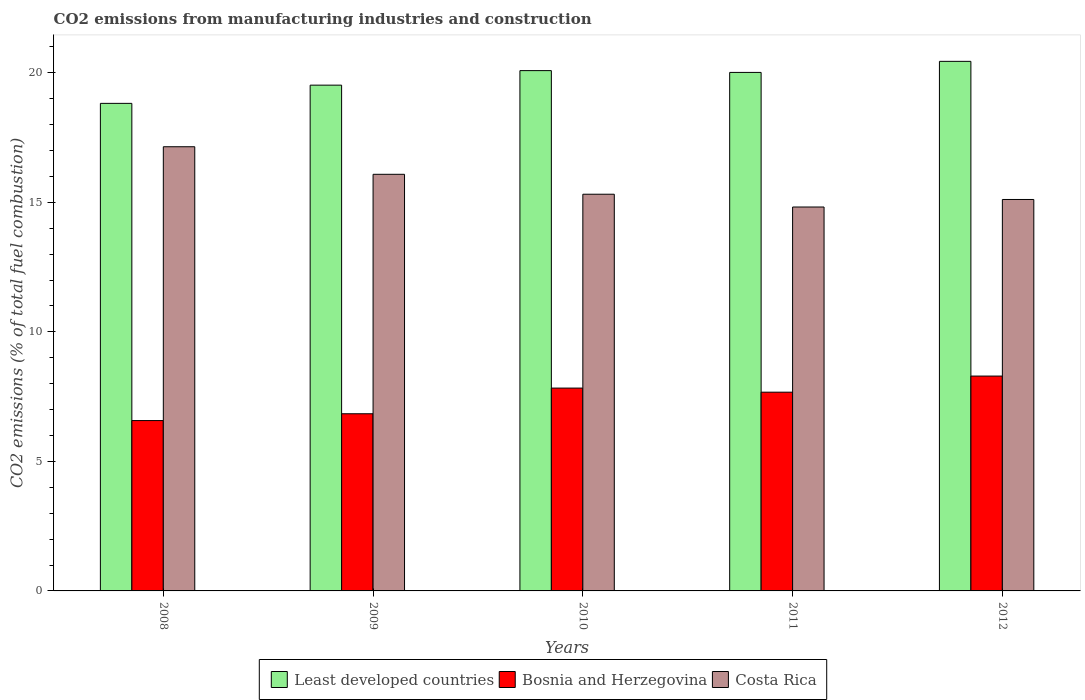How many groups of bars are there?
Your answer should be very brief. 5. Are the number of bars per tick equal to the number of legend labels?
Make the answer very short. Yes. What is the amount of CO2 emitted in Bosnia and Herzegovina in 2010?
Ensure brevity in your answer.  7.83. Across all years, what is the maximum amount of CO2 emitted in Costa Rica?
Provide a short and direct response. 17.15. Across all years, what is the minimum amount of CO2 emitted in Least developed countries?
Provide a short and direct response. 18.82. In which year was the amount of CO2 emitted in Bosnia and Herzegovina maximum?
Your answer should be compact. 2012. What is the total amount of CO2 emitted in Least developed countries in the graph?
Keep it short and to the point. 98.89. What is the difference between the amount of CO2 emitted in Bosnia and Herzegovina in 2008 and that in 2011?
Your answer should be compact. -1.1. What is the difference between the amount of CO2 emitted in Bosnia and Herzegovina in 2008 and the amount of CO2 emitted in Costa Rica in 2011?
Your answer should be compact. -8.24. What is the average amount of CO2 emitted in Costa Rica per year?
Offer a terse response. 15.7. In the year 2012, what is the difference between the amount of CO2 emitted in Least developed countries and amount of CO2 emitted in Bosnia and Herzegovina?
Your response must be concise. 12.15. In how many years, is the amount of CO2 emitted in Costa Rica greater than 11 %?
Your response must be concise. 5. What is the ratio of the amount of CO2 emitted in Costa Rica in 2009 to that in 2012?
Your answer should be compact. 1.06. What is the difference between the highest and the second highest amount of CO2 emitted in Least developed countries?
Make the answer very short. 0.36. What is the difference between the highest and the lowest amount of CO2 emitted in Bosnia and Herzegovina?
Your answer should be compact. 1.72. What does the 3rd bar from the left in 2009 represents?
Make the answer very short. Costa Rica. What does the 3rd bar from the right in 2008 represents?
Provide a succinct answer. Least developed countries. How many bars are there?
Offer a terse response. 15. How many years are there in the graph?
Provide a succinct answer. 5. What is the difference between two consecutive major ticks on the Y-axis?
Your answer should be compact. 5. Are the values on the major ticks of Y-axis written in scientific E-notation?
Provide a succinct answer. No. Does the graph contain any zero values?
Make the answer very short. No. Does the graph contain grids?
Ensure brevity in your answer.  No. Where does the legend appear in the graph?
Give a very brief answer. Bottom center. How many legend labels are there?
Give a very brief answer. 3. What is the title of the graph?
Offer a terse response. CO2 emissions from manufacturing industries and construction. What is the label or title of the Y-axis?
Keep it short and to the point. CO2 emissions (% of total fuel combustion). What is the CO2 emissions (% of total fuel combustion) in Least developed countries in 2008?
Your answer should be very brief. 18.82. What is the CO2 emissions (% of total fuel combustion) in Bosnia and Herzegovina in 2008?
Give a very brief answer. 6.58. What is the CO2 emissions (% of total fuel combustion) in Costa Rica in 2008?
Your answer should be compact. 17.15. What is the CO2 emissions (% of total fuel combustion) in Least developed countries in 2009?
Your answer should be compact. 19.52. What is the CO2 emissions (% of total fuel combustion) in Bosnia and Herzegovina in 2009?
Offer a very short reply. 6.84. What is the CO2 emissions (% of total fuel combustion) in Costa Rica in 2009?
Provide a succinct answer. 16.08. What is the CO2 emissions (% of total fuel combustion) of Least developed countries in 2010?
Make the answer very short. 20.09. What is the CO2 emissions (% of total fuel combustion) of Bosnia and Herzegovina in 2010?
Make the answer very short. 7.83. What is the CO2 emissions (% of total fuel combustion) of Costa Rica in 2010?
Give a very brief answer. 15.31. What is the CO2 emissions (% of total fuel combustion) in Least developed countries in 2011?
Give a very brief answer. 20.02. What is the CO2 emissions (% of total fuel combustion) in Bosnia and Herzegovina in 2011?
Make the answer very short. 7.67. What is the CO2 emissions (% of total fuel combustion) of Costa Rica in 2011?
Keep it short and to the point. 14.82. What is the CO2 emissions (% of total fuel combustion) in Least developed countries in 2012?
Your answer should be very brief. 20.44. What is the CO2 emissions (% of total fuel combustion) in Bosnia and Herzegovina in 2012?
Keep it short and to the point. 8.29. What is the CO2 emissions (% of total fuel combustion) in Costa Rica in 2012?
Give a very brief answer. 15.11. Across all years, what is the maximum CO2 emissions (% of total fuel combustion) of Least developed countries?
Make the answer very short. 20.44. Across all years, what is the maximum CO2 emissions (% of total fuel combustion) of Bosnia and Herzegovina?
Make the answer very short. 8.29. Across all years, what is the maximum CO2 emissions (% of total fuel combustion) in Costa Rica?
Provide a succinct answer. 17.15. Across all years, what is the minimum CO2 emissions (% of total fuel combustion) in Least developed countries?
Provide a short and direct response. 18.82. Across all years, what is the minimum CO2 emissions (% of total fuel combustion) in Bosnia and Herzegovina?
Your answer should be compact. 6.58. Across all years, what is the minimum CO2 emissions (% of total fuel combustion) of Costa Rica?
Your answer should be very brief. 14.82. What is the total CO2 emissions (% of total fuel combustion) in Least developed countries in the graph?
Offer a terse response. 98.89. What is the total CO2 emissions (% of total fuel combustion) of Bosnia and Herzegovina in the graph?
Offer a very short reply. 37.21. What is the total CO2 emissions (% of total fuel combustion) of Costa Rica in the graph?
Offer a terse response. 78.48. What is the difference between the CO2 emissions (% of total fuel combustion) in Least developed countries in 2008 and that in 2009?
Ensure brevity in your answer.  -0.7. What is the difference between the CO2 emissions (% of total fuel combustion) of Bosnia and Herzegovina in 2008 and that in 2009?
Give a very brief answer. -0.26. What is the difference between the CO2 emissions (% of total fuel combustion) in Costa Rica in 2008 and that in 2009?
Your response must be concise. 1.06. What is the difference between the CO2 emissions (% of total fuel combustion) in Least developed countries in 2008 and that in 2010?
Your response must be concise. -1.26. What is the difference between the CO2 emissions (% of total fuel combustion) in Bosnia and Herzegovina in 2008 and that in 2010?
Give a very brief answer. -1.25. What is the difference between the CO2 emissions (% of total fuel combustion) in Costa Rica in 2008 and that in 2010?
Offer a very short reply. 1.83. What is the difference between the CO2 emissions (% of total fuel combustion) in Least developed countries in 2008 and that in 2011?
Make the answer very short. -1.2. What is the difference between the CO2 emissions (% of total fuel combustion) of Bosnia and Herzegovina in 2008 and that in 2011?
Ensure brevity in your answer.  -1.1. What is the difference between the CO2 emissions (% of total fuel combustion) in Costa Rica in 2008 and that in 2011?
Offer a very short reply. 2.33. What is the difference between the CO2 emissions (% of total fuel combustion) in Least developed countries in 2008 and that in 2012?
Offer a very short reply. -1.62. What is the difference between the CO2 emissions (% of total fuel combustion) of Bosnia and Herzegovina in 2008 and that in 2012?
Keep it short and to the point. -1.72. What is the difference between the CO2 emissions (% of total fuel combustion) of Costa Rica in 2008 and that in 2012?
Provide a succinct answer. 2.04. What is the difference between the CO2 emissions (% of total fuel combustion) of Least developed countries in 2009 and that in 2010?
Your answer should be very brief. -0.56. What is the difference between the CO2 emissions (% of total fuel combustion) of Bosnia and Herzegovina in 2009 and that in 2010?
Ensure brevity in your answer.  -0.99. What is the difference between the CO2 emissions (% of total fuel combustion) in Costa Rica in 2009 and that in 2010?
Your response must be concise. 0.77. What is the difference between the CO2 emissions (% of total fuel combustion) in Least developed countries in 2009 and that in 2011?
Offer a terse response. -0.49. What is the difference between the CO2 emissions (% of total fuel combustion) of Bosnia and Herzegovina in 2009 and that in 2011?
Keep it short and to the point. -0.83. What is the difference between the CO2 emissions (% of total fuel combustion) in Costa Rica in 2009 and that in 2011?
Your answer should be very brief. 1.26. What is the difference between the CO2 emissions (% of total fuel combustion) in Least developed countries in 2009 and that in 2012?
Your answer should be compact. -0.92. What is the difference between the CO2 emissions (% of total fuel combustion) in Bosnia and Herzegovina in 2009 and that in 2012?
Your response must be concise. -1.46. What is the difference between the CO2 emissions (% of total fuel combustion) of Costa Rica in 2009 and that in 2012?
Keep it short and to the point. 0.97. What is the difference between the CO2 emissions (% of total fuel combustion) of Least developed countries in 2010 and that in 2011?
Provide a short and direct response. 0.07. What is the difference between the CO2 emissions (% of total fuel combustion) in Bosnia and Herzegovina in 2010 and that in 2011?
Make the answer very short. 0.16. What is the difference between the CO2 emissions (% of total fuel combustion) of Costa Rica in 2010 and that in 2011?
Provide a short and direct response. 0.49. What is the difference between the CO2 emissions (% of total fuel combustion) in Least developed countries in 2010 and that in 2012?
Keep it short and to the point. -0.36. What is the difference between the CO2 emissions (% of total fuel combustion) of Bosnia and Herzegovina in 2010 and that in 2012?
Provide a short and direct response. -0.46. What is the difference between the CO2 emissions (% of total fuel combustion) of Costa Rica in 2010 and that in 2012?
Your answer should be very brief. 0.2. What is the difference between the CO2 emissions (% of total fuel combustion) of Least developed countries in 2011 and that in 2012?
Your response must be concise. -0.43. What is the difference between the CO2 emissions (% of total fuel combustion) in Bosnia and Herzegovina in 2011 and that in 2012?
Your response must be concise. -0.62. What is the difference between the CO2 emissions (% of total fuel combustion) of Costa Rica in 2011 and that in 2012?
Offer a very short reply. -0.29. What is the difference between the CO2 emissions (% of total fuel combustion) of Least developed countries in 2008 and the CO2 emissions (% of total fuel combustion) of Bosnia and Herzegovina in 2009?
Give a very brief answer. 11.98. What is the difference between the CO2 emissions (% of total fuel combustion) of Least developed countries in 2008 and the CO2 emissions (% of total fuel combustion) of Costa Rica in 2009?
Your response must be concise. 2.74. What is the difference between the CO2 emissions (% of total fuel combustion) in Bosnia and Herzegovina in 2008 and the CO2 emissions (% of total fuel combustion) in Costa Rica in 2009?
Offer a terse response. -9.51. What is the difference between the CO2 emissions (% of total fuel combustion) in Least developed countries in 2008 and the CO2 emissions (% of total fuel combustion) in Bosnia and Herzegovina in 2010?
Make the answer very short. 10.99. What is the difference between the CO2 emissions (% of total fuel combustion) of Least developed countries in 2008 and the CO2 emissions (% of total fuel combustion) of Costa Rica in 2010?
Ensure brevity in your answer.  3.51. What is the difference between the CO2 emissions (% of total fuel combustion) in Bosnia and Herzegovina in 2008 and the CO2 emissions (% of total fuel combustion) in Costa Rica in 2010?
Ensure brevity in your answer.  -8.74. What is the difference between the CO2 emissions (% of total fuel combustion) of Least developed countries in 2008 and the CO2 emissions (% of total fuel combustion) of Bosnia and Herzegovina in 2011?
Your response must be concise. 11.15. What is the difference between the CO2 emissions (% of total fuel combustion) of Least developed countries in 2008 and the CO2 emissions (% of total fuel combustion) of Costa Rica in 2011?
Your answer should be very brief. 4. What is the difference between the CO2 emissions (% of total fuel combustion) of Bosnia and Herzegovina in 2008 and the CO2 emissions (% of total fuel combustion) of Costa Rica in 2011?
Provide a succinct answer. -8.24. What is the difference between the CO2 emissions (% of total fuel combustion) of Least developed countries in 2008 and the CO2 emissions (% of total fuel combustion) of Bosnia and Herzegovina in 2012?
Keep it short and to the point. 10.53. What is the difference between the CO2 emissions (% of total fuel combustion) in Least developed countries in 2008 and the CO2 emissions (% of total fuel combustion) in Costa Rica in 2012?
Your answer should be compact. 3.71. What is the difference between the CO2 emissions (% of total fuel combustion) of Bosnia and Herzegovina in 2008 and the CO2 emissions (% of total fuel combustion) of Costa Rica in 2012?
Offer a very short reply. -8.53. What is the difference between the CO2 emissions (% of total fuel combustion) in Least developed countries in 2009 and the CO2 emissions (% of total fuel combustion) in Bosnia and Herzegovina in 2010?
Offer a terse response. 11.69. What is the difference between the CO2 emissions (% of total fuel combustion) of Least developed countries in 2009 and the CO2 emissions (% of total fuel combustion) of Costa Rica in 2010?
Offer a very short reply. 4.21. What is the difference between the CO2 emissions (% of total fuel combustion) in Bosnia and Herzegovina in 2009 and the CO2 emissions (% of total fuel combustion) in Costa Rica in 2010?
Provide a short and direct response. -8.47. What is the difference between the CO2 emissions (% of total fuel combustion) in Least developed countries in 2009 and the CO2 emissions (% of total fuel combustion) in Bosnia and Herzegovina in 2011?
Offer a very short reply. 11.85. What is the difference between the CO2 emissions (% of total fuel combustion) of Least developed countries in 2009 and the CO2 emissions (% of total fuel combustion) of Costa Rica in 2011?
Your answer should be very brief. 4.7. What is the difference between the CO2 emissions (% of total fuel combustion) of Bosnia and Herzegovina in 2009 and the CO2 emissions (% of total fuel combustion) of Costa Rica in 2011?
Your answer should be compact. -7.98. What is the difference between the CO2 emissions (% of total fuel combustion) of Least developed countries in 2009 and the CO2 emissions (% of total fuel combustion) of Bosnia and Herzegovina in 2012?
Your answer should be very brief. 11.23. What is the difference between the CO2 emissions (% of total fuel combustion) in Least developed countries in 2009 and the CO2 emissions (% of total fuel combustion) in Costa Rica in 2012?
Your response must be concise. 4.41. What is the difference between the CO2 emissions (% of total fuel combustion) of Bosnia and Herzegovina in 2009 and the CO2 emissions (% of total fuel combustion) of Costa Rica in 2012?
Give a very brief answer. -8.27. What is the difference between the CO2 emissions (% of total fuel combustion) of Least developed countries in 2010 and the CO2 emissions (% of total fuel combustion) of Bosnia and Herzegovina in 2011?
Your answer should be compact. 12.41. What is the difference between the CO2 emissions (% of total fuel combustion) of Least developed countries in 2010 and the CO2 emissions (% of total fuel combustion) of Costa Rica in 2011?
Your answer should be very brief. 5.27. What is the difference between the CO2 emissions (% of total fuel combustion) of Bosnia and Herzegovina in 2010 and the CO2 emissions (% of total fuel combustion) of Costa Rica in 2011?
Ensure brevity in your answer.  -6.99. What is the difference between the CO2 emissions (% of total fuel combustion) in Least developed countries in 2010 and the CO2 emissions (% of total fuel combustion) in Bosnia and Herzegovina in 2012?
Your answer should be compact. 11.79. What is the difference between the CO2 emissions (% of total fuel combustion) of Least developed countries in 2010 and the CO2 emissions (% of total fuel combustion) of Costa Rica in 2012?
Make the answer very short. 4.97. What is the difference between the CO2 emissions (% of total fuel combustion) in Bosnia and Herzegovina in 2010 and the CO2 emissions (% of total fuel combustion) in Costa Rica in 2012?
Make the answer very short. -7.28. What is the difference between the CO2 emissions (% of total fuel combustion) of Least developed countries in 2011 and the CO2 emissions (% of total fuel combustion) of Bosnia and Herzegovina in 2012?
Your answer should be very brief. 11.72. What is the difference between the CO2 emissions (% of total fuel combustion) of Least developed countries in 2011 and the CO2 emissions (% of total fuel combustion) of Costa Rica in 2012?
Give a very brief answer. 4.91. What is the difference between the CO2 emissions (% of total fuel combustion) of Bosnia and Herzegovina in 2011 and the CO2 emissions (% of total fuel combustion) of Costa Rica in 2012?
Offer a very short reply. -7.44. What is the average CO2 emissions (% of total fuel combustion) in Least developed countries per year?
Keep it short and to the point. 19.78. What is the average CO2 emissions (% of total fuel combustion) in Bosnia and Herzegovina per year?
Ensure brevity in your answer.  7.44. What is the average CO2 emissions (% of total fuel combustion) in Costa Rica per year?
Your response must be concise. 15.7. In the year 2008, what is the difference between the CO2 emissions (% of total fuel combustion) of Least developed countries and CO2 emissions (% of total fuel combustion) of Bosnia and Herzegovina?
Offer a terse response. 12.24. In the year 2008, what is the difference between the CO2 emissions (% of total fuel combustion) of Least developed countries and CO2 emissions (% of total fuel combustion) of Costa Rica?
Provide a short and direct response. 1.67. In the year 2008, what is the difference between the CO2 emissions (% of total fuel combustion) of Bosnia and Herzegovina and CO2 emissions (% of total fuel combustion) of Costa Rica?
Keep it short and to the point. -10.57. In the year 2009, what is the difference between the CO2 emissions (% of total fuel combustion) in Least developed countries and CO2 emissions (% of total fuel combustion) in Bosnia and Herzegovina?
Keep it short and to the point. 12.69. In the year 2009, what is the difference between the CO2 emissions (% of total fuel combustion) of Least developed countries and CO2 emissions (% of total fuel combustion) of Costa Rica?
Offer a terse response. 3.44. In the year 2009, what is the difference between the CO2 emissions (% of total fuel combustion) in Bosnia and Herzegovina and CO2 emissions (% of total fuel combustion) in Costa Rica?
Ensure brevity in your answer.  -9.24. In the year 2010, what is the difference between the CO2 emissions (% of total fuel combustion) of Least developed countries and CO2 emissions (% of total fuel combustion) of Bosnia and Herzegovina?
Offer a terse response. 12.26. In the year 2010, what is the difference between the CO2 emissions (% of total fuel combustion) of Least developed countries and CO2 emissions (% of total fuel combustion) of Costa Rica?
Offer a very short reply. 4.77. In the year 2010, what is the difference between the CO2 emissions (% of total fuel combustion) of Bosnia and Herzegovina and CO2 emissions (% of total fuel combustion) of Costa Rica?
Your answer should be very brief. -7.48. In the year 2011, what is the difference between the CO2 emissions (% of total fuel combustion) of Least developed countries and CO2 emissions (% of total fuel combustion) of Bosnia and Herzegovina?
Offer a very short reply. 12.34. In the year 2011, what is the difference between the CO2 emissions (% of total fuel combustion) of Least developed countries and CO2 emissions (% of total fuel combustion) of Costa Rica?
Offer a terse response. 5.2. In the year 2011, what is the difference between the CO2 emissions (% of total fuel combustion) of Bosnia and Herzegovina and CO2 emissions (% of total fuel combustion) of Costa Rica?
Offer a very short reply. -7.15. In the year 2012, what is the difference between the CO2 emissions (% of total fuel combustion) in Least developed countries and CO2 emissions (% of total fuel combustion) in Bosnia and Herzegovina?
Offer a terse response. 12.15. In the year 2012, what is the difference between the CO2 emissions (% of total fuel combustion) of Least developed countries and CO2 emissions (% of total fuel combustion) of Costa Rica?
Your response must be concise. 5.33. In the year 2012, what is the difference between the CO2 emissions (% of total fuel combustion) in Bosnia and Herzegovina and CO2 emissions (% of total fuel combustion) in Costa Rica?
Keep it short and to the point. -6.82. What is the ratio of the CO2 emissions (% of total fuel combustion) in Bosnia and Herzegovina in 2008 to that in 2009?
Your answer should be very brief. 0.96. What is the ratio of the CO2 emissions (% of total fuel combustion) of Costa Rica in 2008 to that in 2009?
Offer a very short reply. 1.07. What is the ratio of the CO2 emissions (% of total fuel combustion) in Least developed countries in 2008 to that in 2010?
Your response must be concise. 0.94. What is the ratio of the CO2 emissions (% of total fuel combustion) of Bosnia and Herzegovina in 2008 to that in 2010?
Make the answer very short. 0.84. What is the ratio of the CO2 emissions (% of total fuel combustion) in Costa Rica in 2008 to that in 2010?
Offer a very short reply. 1.12. What is the ratio of the CO2 emissions (% of total fuel combustion) of Least developed countries in 2008 to that in 2011?
Provide a short and direct response. 0.94. What is the ratio of the CO2 emissions (% of total fuel combustion) in Bosnia and Herzegovina in 2008 to that in 2011?
Your response must be concise. 0.86. What is the ratio of the CO2 emissions (% of total fuel combustion) in Costa Rica in 2008 to that in 2011?
Offer a terse response. 1.16. What is the ratio of the CO2 emissions (% of total fuel combustion) of Least developed countries in 2008 to that in 2012?
Your response must be concise. 0.92. What is the ratio of the CO2 emissions (% of total fuel combustion) in Bosnia and Herzegovina in 2008 to that in 2012?
Offer a terse response. 0.79. What is the ratio of the CO2 emissions (% of total fuel combustion) in Costa Rica in 2008 to that in 2012?
Ensure brevity in your answer.  1.13. What is the ratio of the CO2 emissions (% of total fuel combustion) in Least developed countries in 2009 to that in 2010?
Make the answer very short. 0.97. What is the ratio of the CO2 emissions (% of total fuel combustion) of Bosnia and Herzegovina in 2009 to that in 2010?
Your answer should be very brief. 0.87. What is the ratio of the CO2 emissions (% of total fuel combustion) of Costa Rica in 2009 to that in 2010?
Your answer should be very brief. 1.05. What is the ratio of the CO2 emissions (% of total fuel combustion) in Least developed countries in 2009 to that in 2011?
Provide a short and direct response. 0.98. What is the ratio of the CO2 emissions (% of total fuel combustion) of Bosnia and Herzegovina in 2009 to that in 2011?
Ensure brevity in your answer.  0.89. What is the ratio of the CO2 emissions (% of total fuel combustion) in Costa Rica in 2009 to that in 2011?
Keep it short and to the point. 1.09. What is the ratio of the CO2 emissions (% of total fuel combustion) in Least developed countries in 2009 to that in 2012?
Make the answer very short. 0.96. What is the ratio of the CO2 emissions (% of total fuel combustion) of Bosnia and Herzegovina in 2009 to that in 2012?
Keep it short and to the point. 0.82. What is the ratio of the CO2 emissions (% of total fuel combustion) in Costa Rica in 2009 to that in 2012?
Ensure brevity in your answer.  1.06. What is the ratio of the CO2 emissions (% of total fuel combustion) of Least developed countries in 2010 to that in 2011?
Offer a very short reply. 1. What is the ratio of the CO2 emissions (% of total fuel combustion) of Bosnia and Herzegovina in 2010 to that in 2011?
Your response must be concise. 1.02. What is the ratio of the CO2 emissions (% of total fuel combustion) in Costa Rica in 2010 to that in 2011?
Provide a short and direct response. 1.03. What is the ratio of the CO2 emissions (% of total fuel combustion) of Least developed countries in 2010 to that in 2012?
Provide a short and direct response. 0.98. What is the ratio of the CO2 emissions (% of total fuel combustion) in Bosnia and Herzegovina in 2010 to that in 2012?
Provide a short and direct response. 0.94. What is the ratio of the CO2 emissions (% of total fuel combustion) in Costa Rica in 2010 to that in 2012?
Provide a succinct answer. 1.01. What is the ratio of the CO2 emissions (% of total fuel combustion) in Least developed countries in 2011 to that in 2012?
Provide a short and direct response. 0.98. What is the ratio of the CO2 emissions (% of total fuel combustion) of Bosnia and Herzegovina in 2011 to that in 2012?
Offer a very short reply. 0.93. What is the ratio of the CO2 emissions (% of total fuel combustion) in Costa Rica in 2011 to that in 2012?
Provide a succinct answer. 0.98. What is the difference between the highest and the second highest CO2 emissions (% of total fuel combustion) of Least developed countries?
Provide a short and direct response. 0.36. What is the difference between the highest and the second highest CO2 emissions (% of total fuel combustion) in Bosnia and Herzegovina?
Ensure brevity in your answer.  0.46. What is the difference between the highest and the second highest CO2 emissions (% of total fuel combustion) in Costa Rica?
Your answer should be compact. 1.06. What is the difference between the highest and the lowest CO2 emissions (% of total fuel combustion) in Least developed countries?
Ensure brevity in your answer.  1.62. What is the difference between the highest and the lowest CO2 emissions (% of total fuel combustion) in Bosnia and Herzegovina?
Offer a terse response. 1.72. What is the difference between the highest and the lowest CO2 emissions (% of total fuel combustion) in Costa Rica?
Your answer should be very brief. 2.33. 